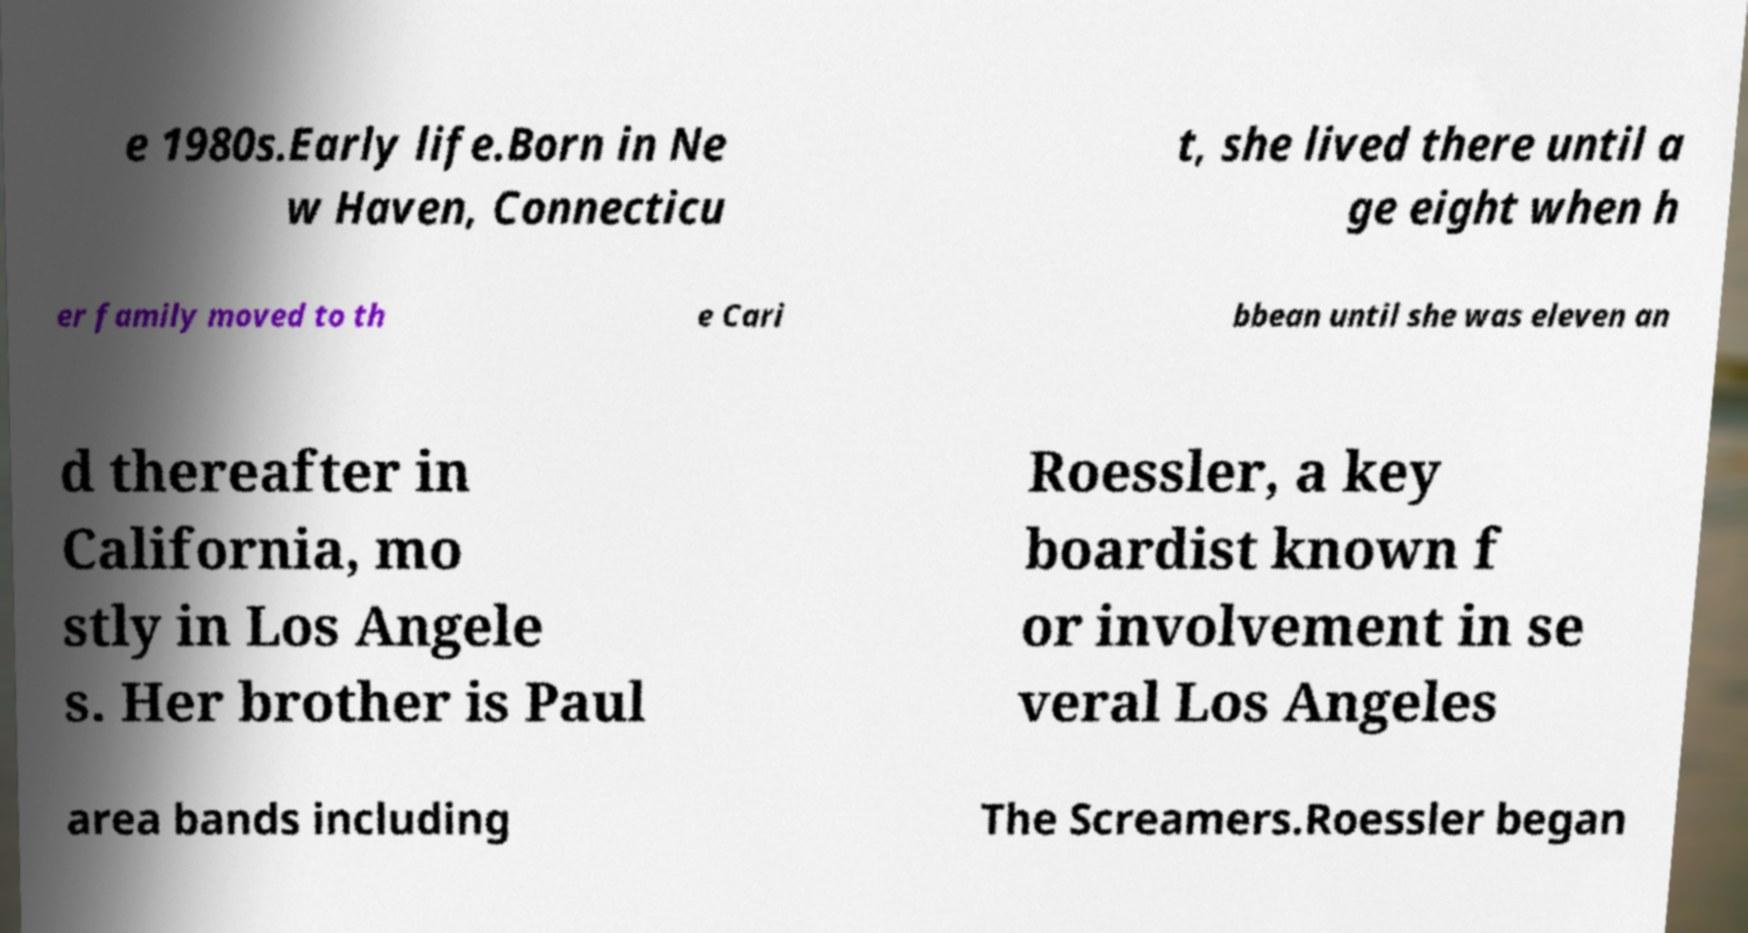Could you extract and type out the text from this image? e 1980s.Early life.Born in Ne w Haven, Connecticu t, she lived there until a ge eight when h er family moved to th e Cari bbean until she was eleven an d thereafter in California, mo stly in Los Angele s. Her brother is Paul Roessler, a key boardist known f or involvement in se veral Los Angeles area bands including The Screamers.Roessler began 